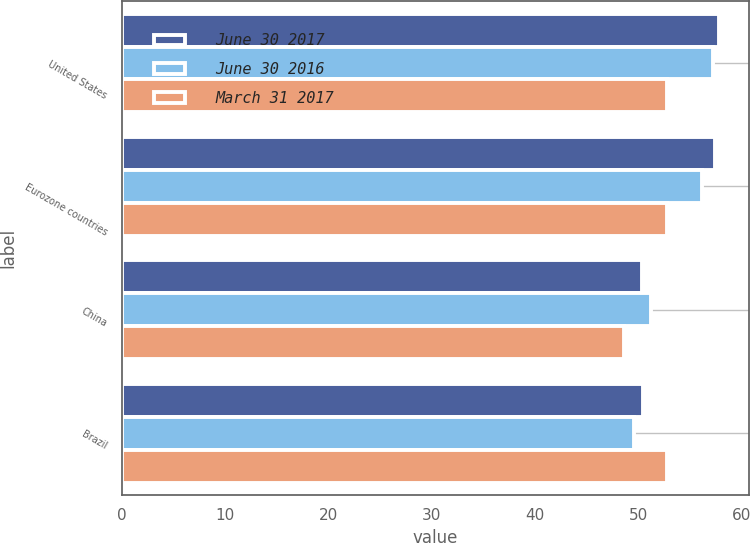Convert chart. <chart><loc_0><loc_0><loc_500><loc_500><stacked_bar_chart><ecel><fcel>United States<fcel>Eurozone countries<fcel>China<fcel>Brazil<nl><fcel>June 30 2017<fcel>57.8<fcel>57.4<fcel>50.4<fcel>50.5<nl><fcel>June 30 2016<fcel>57.2<fcel>56.2<fcel>51.2<fcel>49.6<nl><fcel>March 31 2017<fcel>52.8<fcel>52.8<fcel>48.6<fcel>52.8<nl></chart> 